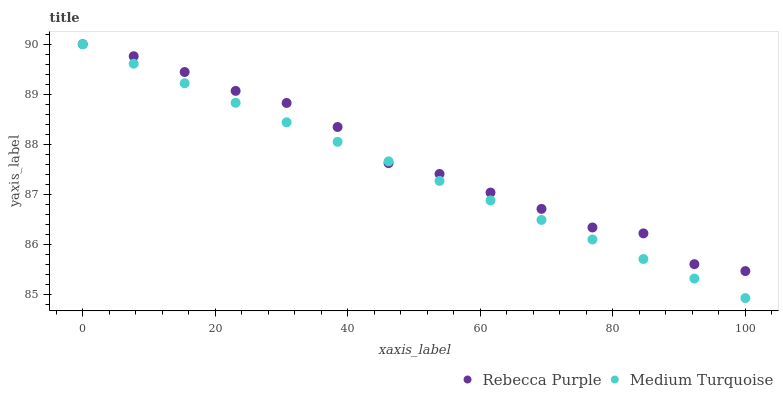Does Medium Turquoise have the minimum area under the curve?
Answer yes or no. Yes. Does Rebecca Purple have the maximum area under the curve?
Answer yes or no. Yes. Does Medium Turquoise have the maximum area under the curve?
Answer yes or no. No. Is Medium Turquoise the smoothest?
Answer yes or no. Yes. Is Rebecca Purple the roughest?
Answer yes or no. Yes. Is Medium Turquoise the roughest?
Answer yes or no. No. Does Medium Turquoise have the lowest value?
Answer yes or no. Yes. Does Medium Turquoise have the highest value?
Answer yes or no. Yes. Does Medium Turquoise intersect Rebecca Purple?
Answer yes or no. Yes. Is Medium Turquoise less than Rebecca Purple?
Answer yes or no. No. Is Medium Turquoise greater than Rebecca Purple?
Answer yes or no. No. 